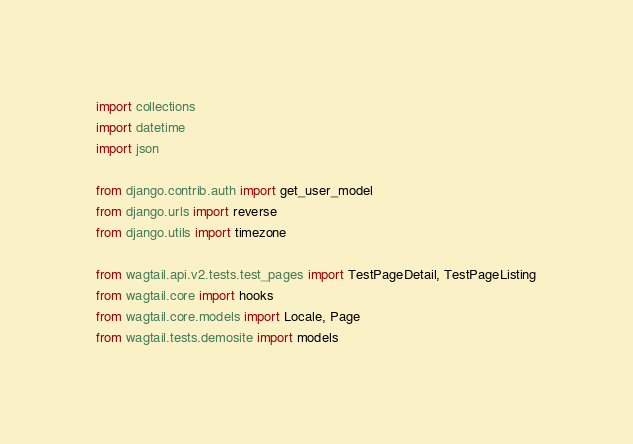<code> <loc_0><loc_0><loc_500><loc_500><_Python_>import collections
import datetime
import json

from django.contrib.auth import get_user_model
from django.urls import reverse
from django.utils import timezone

from wagtail.api.v2.tests.test_pages import TestPageDetail, TestPageListing
from wagtail.core import hooks
from wagtail.core.models import Locale, Page
from wagtail.tests.demosite import models</code> 